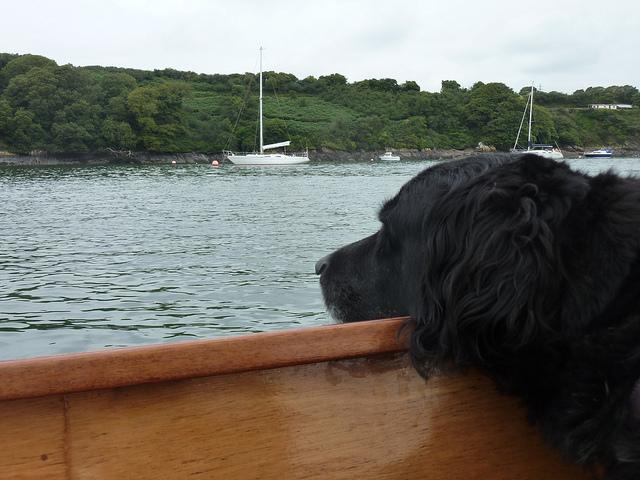What color is the dog?
Quick response, please. Black. Where is the nearest anchored sailboat?
Be succinct. By shore. Does the dog appear wet?
Answer briefly. No. 